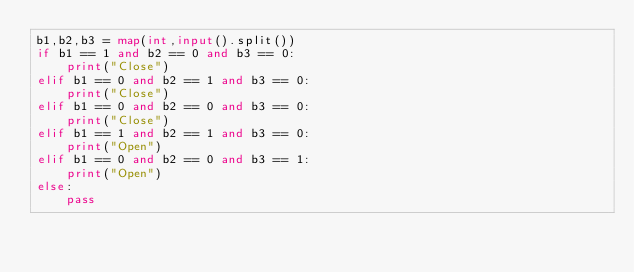<code> <loc_0><loc_0><loc_500><loc_500><_Python_>b1,b2,b3 = map(int,input().split())
if b1 == 1 and b2 == 0 and b3 == 0:
    print("Close")
elif b1 == 0 and b2 == 1 and b3 == 0:
    print("Close")
elif b1 == 0 and b2 == 0 and b3 == 0:
    print("Close")
elif b1 == 1 and b2 == 1 and b3 == 0: 
    print("Open")
elif b1 == 0 and b2 == 0 and b3 == 1:
    print("Open")
else:
    pass
</code> 